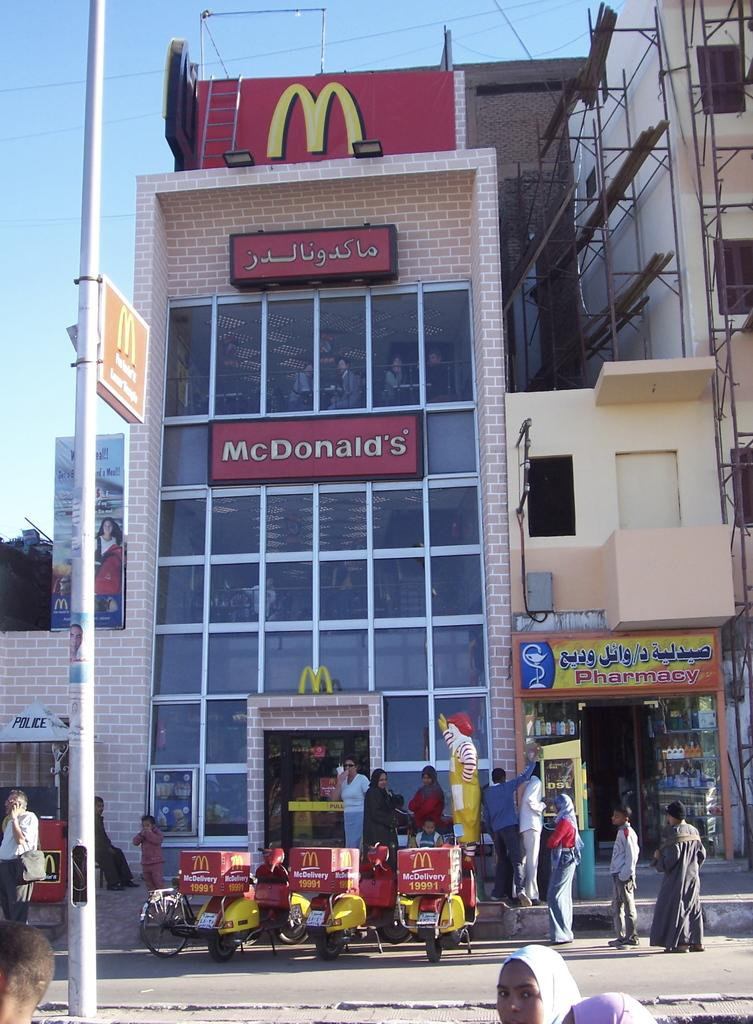<image>
Create a compact narrative representing the image presented. Three McDonald's delivery scooters sit outside a McDonald's restaurant. 